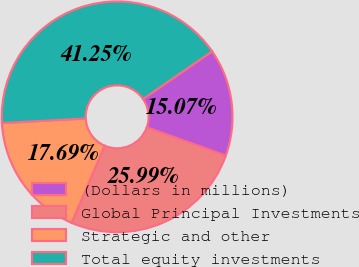Convert chart to OTSL. <chart><loc_0><loc_0><loc_500><loc_500><pie_chart><fcel>(Dollars in millions)<fcel>Global Principal Investments<fcel>Strategic and other<fcel>Total equity investments<nl><fcel>15.07%<fcel>25.99%<fcel>17.69%<fcel>41.25%<nl></chart> 